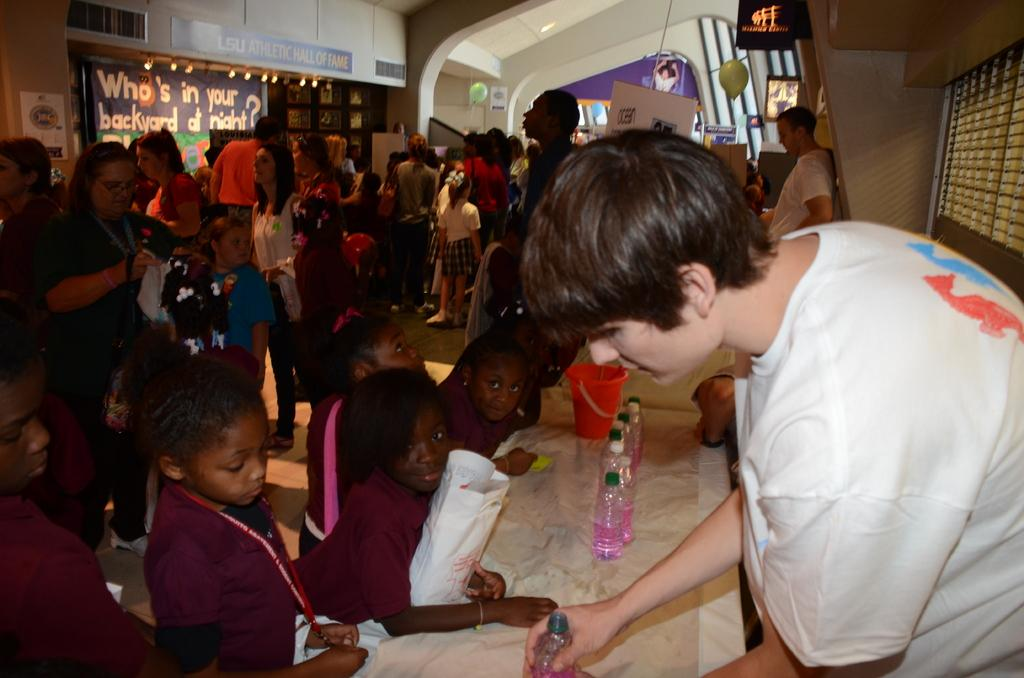What can be seen in the image involving people? There are people standing in the image. What object is present that might be used for covering something? There is a cover in the image. What type of container is visible in the image? There is a bucket in the image. What items are present that might contain liquids? There are bottles in the image. What can be seen on the wall in the image? There is a poster on the wall in the image. What type of mine is depicted in the image? There is no mine present in the image; it features people, a cover, a bucket, bottles, and a poster on the wall. What kind of lunch is being served in the image? There is no lunch present in the image. 